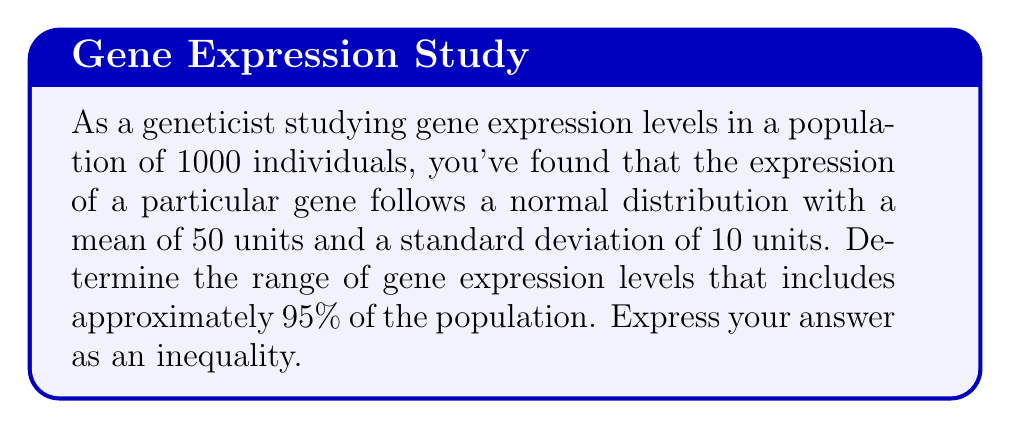Give your solution to this math problem. To solve this problem, we'll use the properties of the normal distribution and the concept of standard deviations:

1) In a normal distribution, approximately 95% of the data falls within 2 standard deviations of the mean.

2) Given:
   - Mean (μ) = 50 units
   - Standard deviation (σ) = 10 units

3) The range we're looking for is:
   $$(μ - 2σ) \leq x \leq (μ + 2σ)$$

4) Substituting the values:
   $$(50 - 2(10)) \leq x \leq (50 + 2(10))$$

5) Simplifying:
   $$(50 - 20) \leq x \leq (50 + 20)$$
   $$30 \leq x \leq 70$$

This inequality represents the range of gene expression levels that includes approximately 95% of the population.
Answer: $$30 \leq x \leq 70$$ 